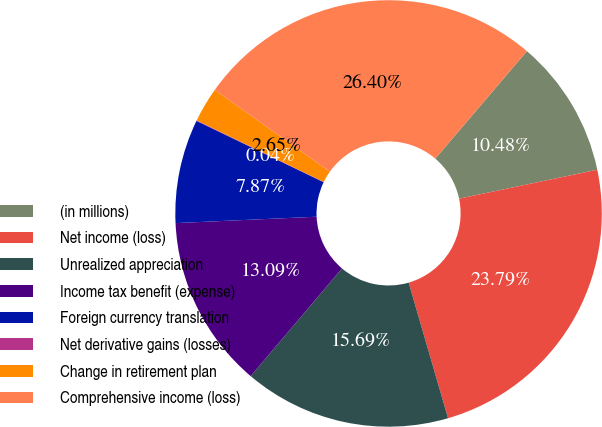Convert chart to OTSL. <chart><loc_0><loc_0><loc_500><loc_500><pie_chart><fcel>(in millions)<fcel>Net income (loss)<fcel>Unrealized appreciation<fcel>Income tax benefit (expense)<fcel>Foreign currency translation<fcel>Net derivative gains (losses)<fcel>Change in retirement plan<fcel>Comprehensive income (loss)<nl><fcel>10.48%<fcel>23.79%<fcel>15.69%<fcel>13.09%<fcel>7.87%<fcel>0.04%<fcel>2.65%<fcel>26.4%<nl></chart> 